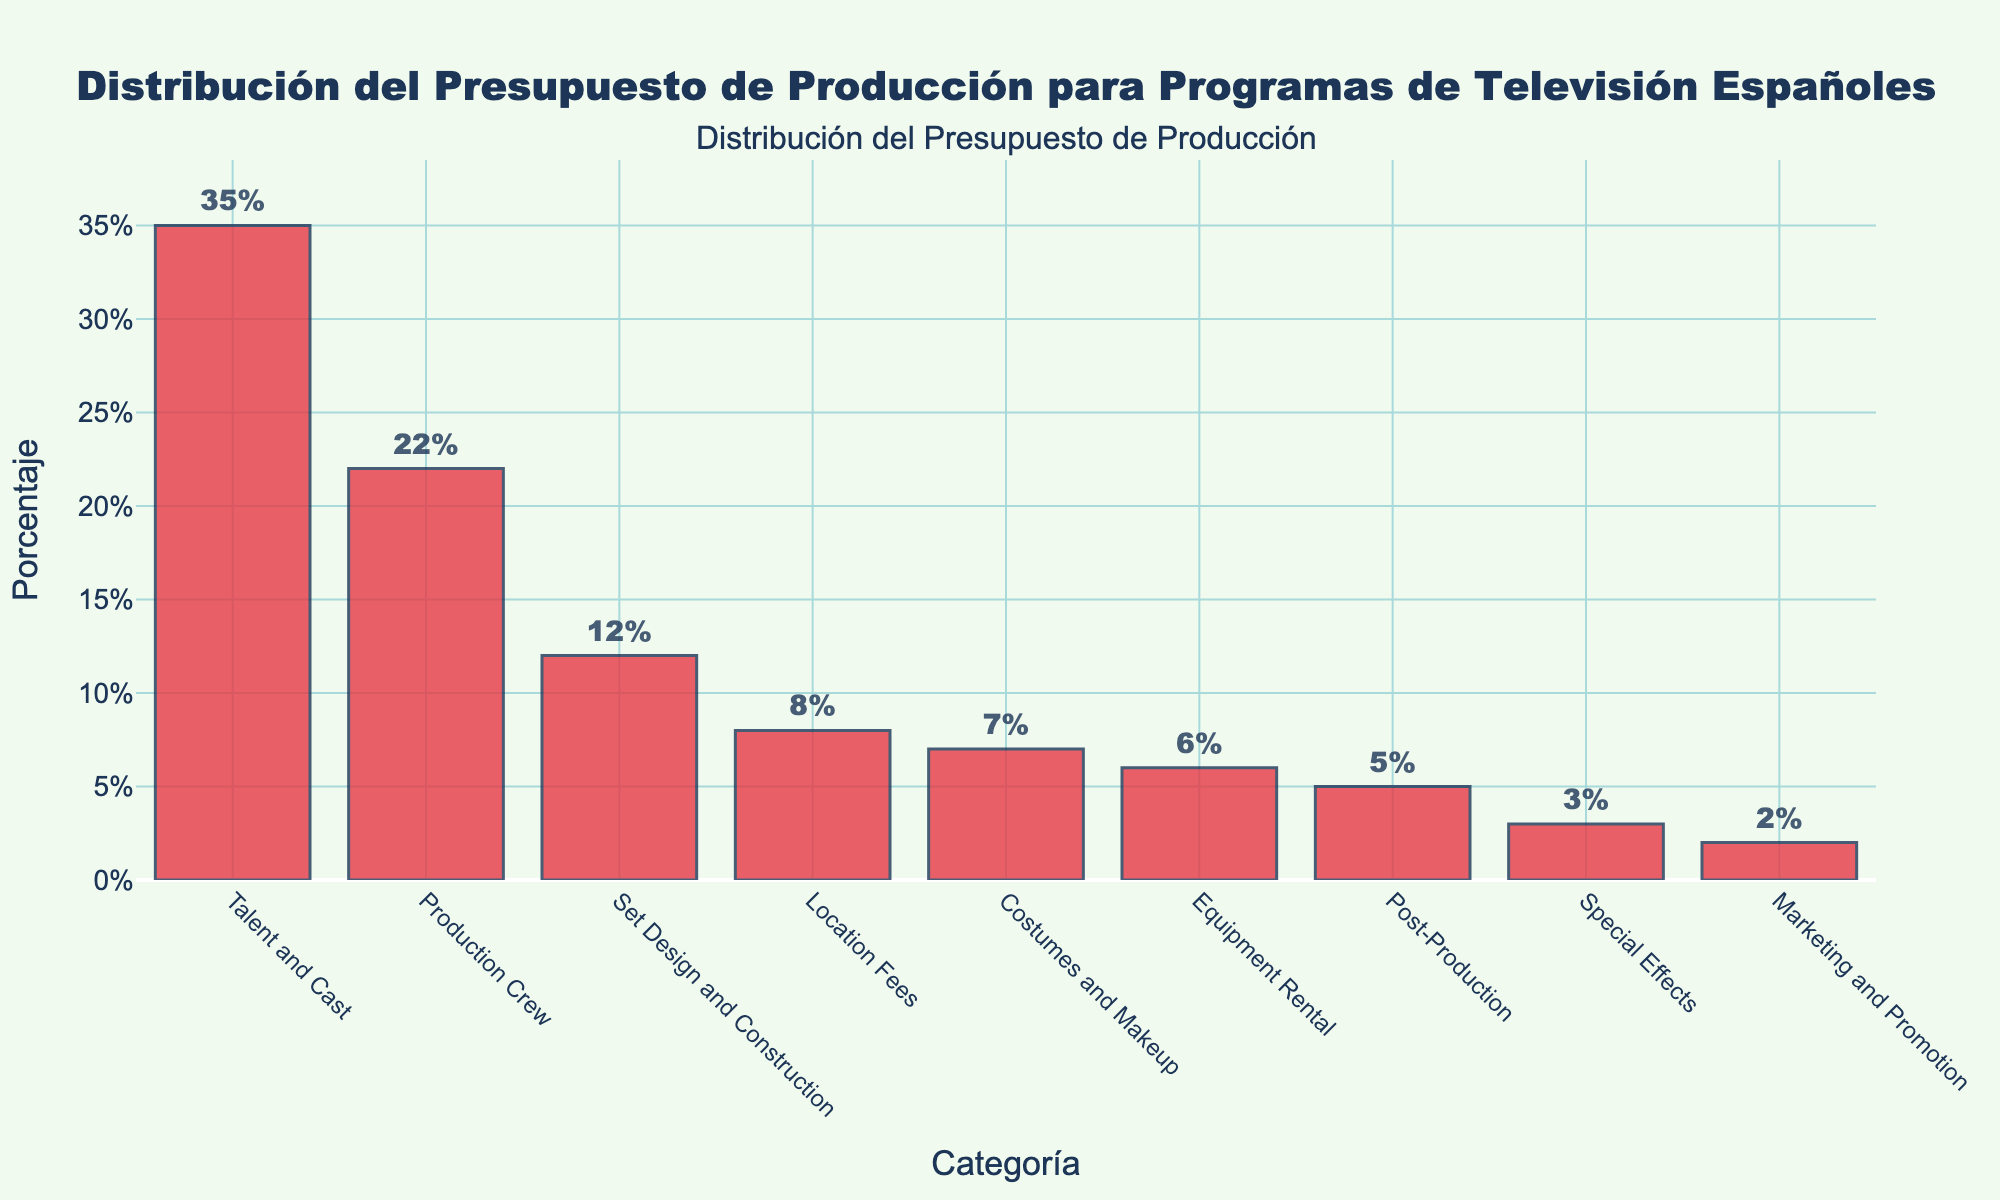What's the category with the highest budget allocation? The category with the highest budget allocation is the one with the tallest bar, which is labeled 'Talent and Cast'.
Answer: Talent and Cast What is the total percentage of the budget allocated to Set Design and Construction and Equipment Rental combined? Add the percentages of Set Design and Construction (12%) and Equipment Rental (6%). 12 + 6 = 18
Answer: 18% Which category has a higher budget allocation: Costumes and Makeup or Post-Production? Compare the heights of the bars for Costumes and Makeup (7%) and Post-Production (5%). Since 7% is greater than 5%, Costumes and Makeup has a higher allocation.
Answer: Costumes and Makeup What's the percentage difference between the highest and lowest budget allocation categories? The highest is Talent and Cast with 35% and the lowest is Marketing and Promotion with 2%. The difference is 35 - 2 = 33%.
Answer: 33% How much more is allocated to Location Fees compared to Special Effects? Subtract the percentage of Special Effects (3%) from the percentage of Location Fees (8%). 8 - 3 = 5% more for Location Fees.
Answer: 5% What is the average budget allocation across all categories? Add up all percentages (35 + 22 + 12 + 8 + 7 + 6 + 5 + 3 + 2 = 100) and divide by the number of categories (9). The average is 100/9 ≈ 11.11%.
Answer: 11.11% If the combined budget for Post-Production and Special Effects is doubled, what would their new combined percentage be? First, add the percentages of Post-Production (5%) and Special Effects (3%), which is 5 + 3 = 8%. Doubling this combined percentage gives 8 * 2 = 16%.
Answer: 16% Are there more categories with budget allocations above or below 10%? Count the categories above 10% (Talent and Cast, Production Crew, Set Design and Construction) which are 3, and those below 10% (Location Fees, Costumes and Makeup, Equipment Rental, Post-Production, Special Effects, Marketing and Promotion) which are 6. There are more categories below 10%.
Answer: Below 10% Which category has the third-highest budget allocation and what is its percentage? The third highest bar corresponds to Set Design and Construction with a percentage of 12%.
Answer: Set Design and Construction, 12% What is the combined total percentage for categories allocated below 10%? Add up the percentages for categories below 10% (Location Fees 8%, Costumes and Makeup 7%, Equipment Rental 6%, Post-Production 5%, Special Effects 3%, Marketing and Promotion 2%) which gives 8 + 7 + 6 + 5 + 3 + 2 = 31%.
Answer: 31% 